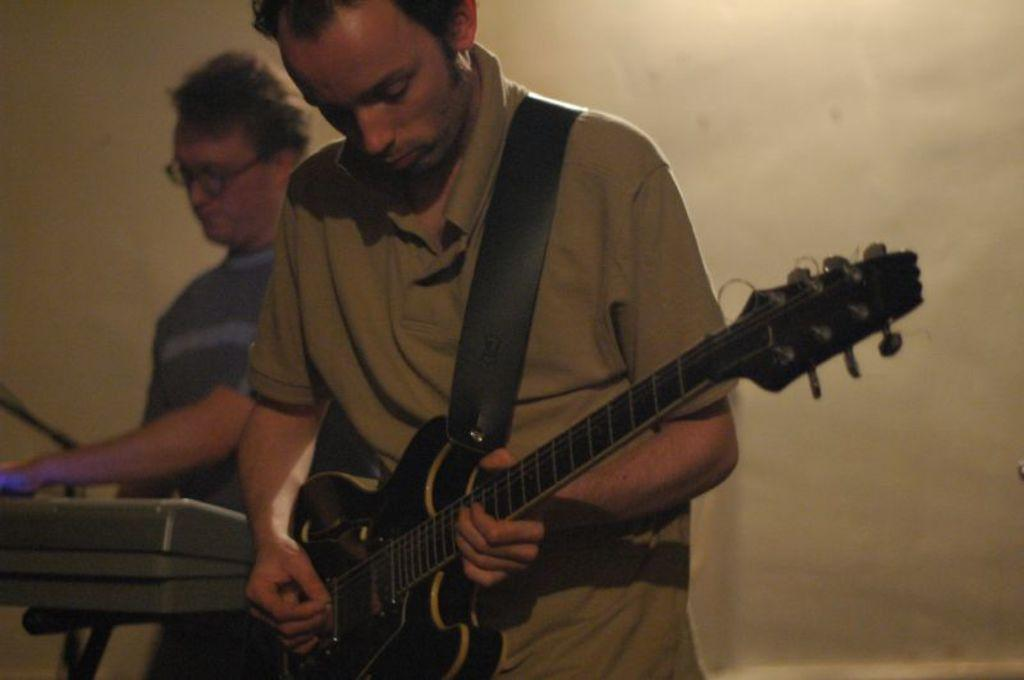How many people are in the image? There are two men in the image. What are the men doing in the image? One man is playing a guitar, and another man is playing a keyboard. How many toes can be seen on the guitar player's feet in the image? There is no information about the guitar player's toes in the image, so it cannot be determined. 